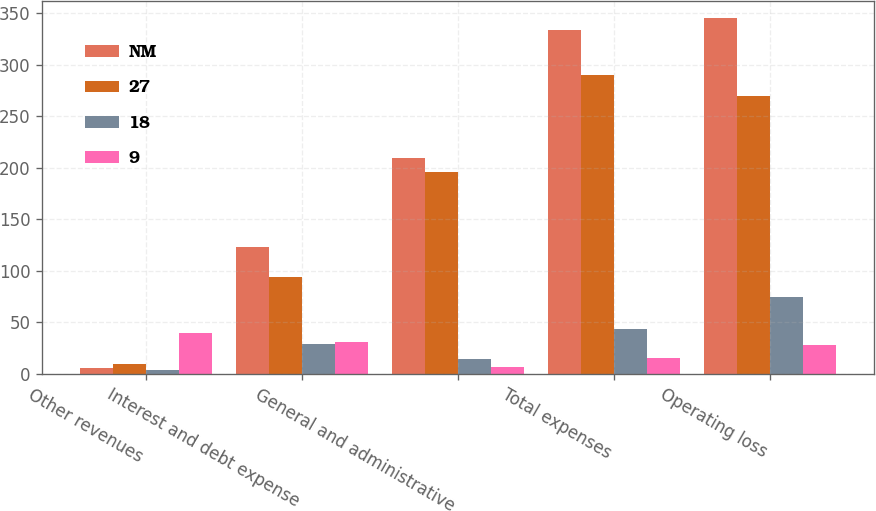Convert chart to OTSL. <chart><loc_0><loc_0><loc_500><loc_500><stacked_bar_chart><ecel><fcel>Other revenues<fcel>Interest and debt expense<fcel>General and administrative<fcel>Total expenses<fcel>Operating loss<nl><fcel>NM<fcel>6<fcel>123<fcel>210<fcel>334<fcel>345<nl><fcel>27<fcel>10<fcel>94<fcel>196<fcel>290<fcel>270<nl><fcel>18<fcel>4<fcel>29<fcel>14<fcel>44<fcel>75<nl><fcel>9<fcel>40<fcel>31<fcel>7<fcel>15<fcel>28<nl></chart> 